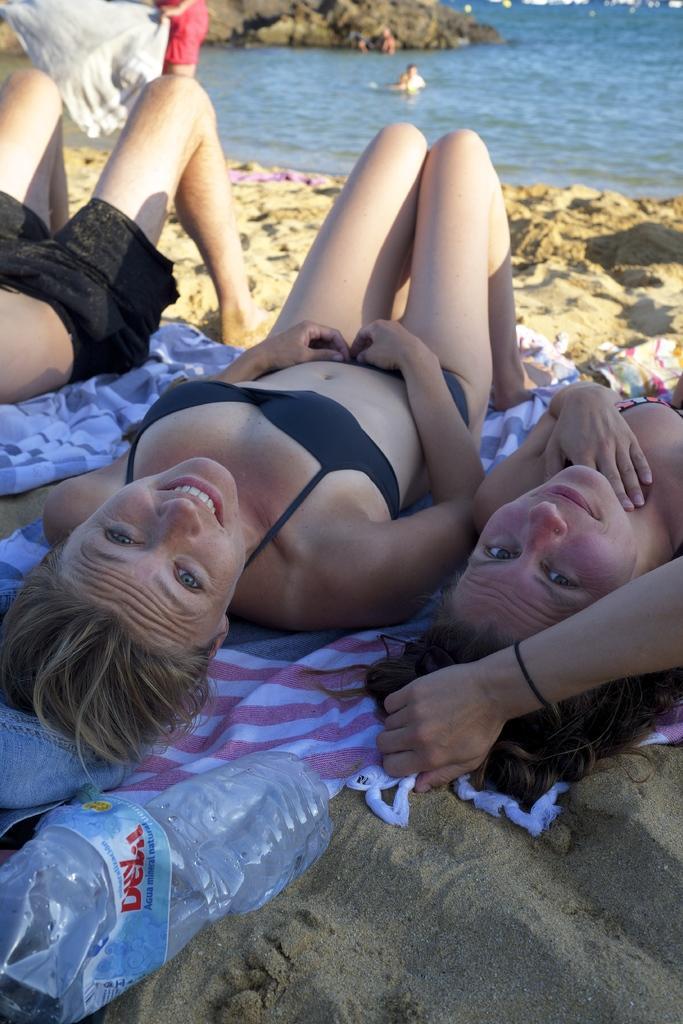Could you give a brief overview of what you see in this image? In this image I can see people among them some are lying on clothes. In the background I can see people in the water. Here I can see a bottle. 